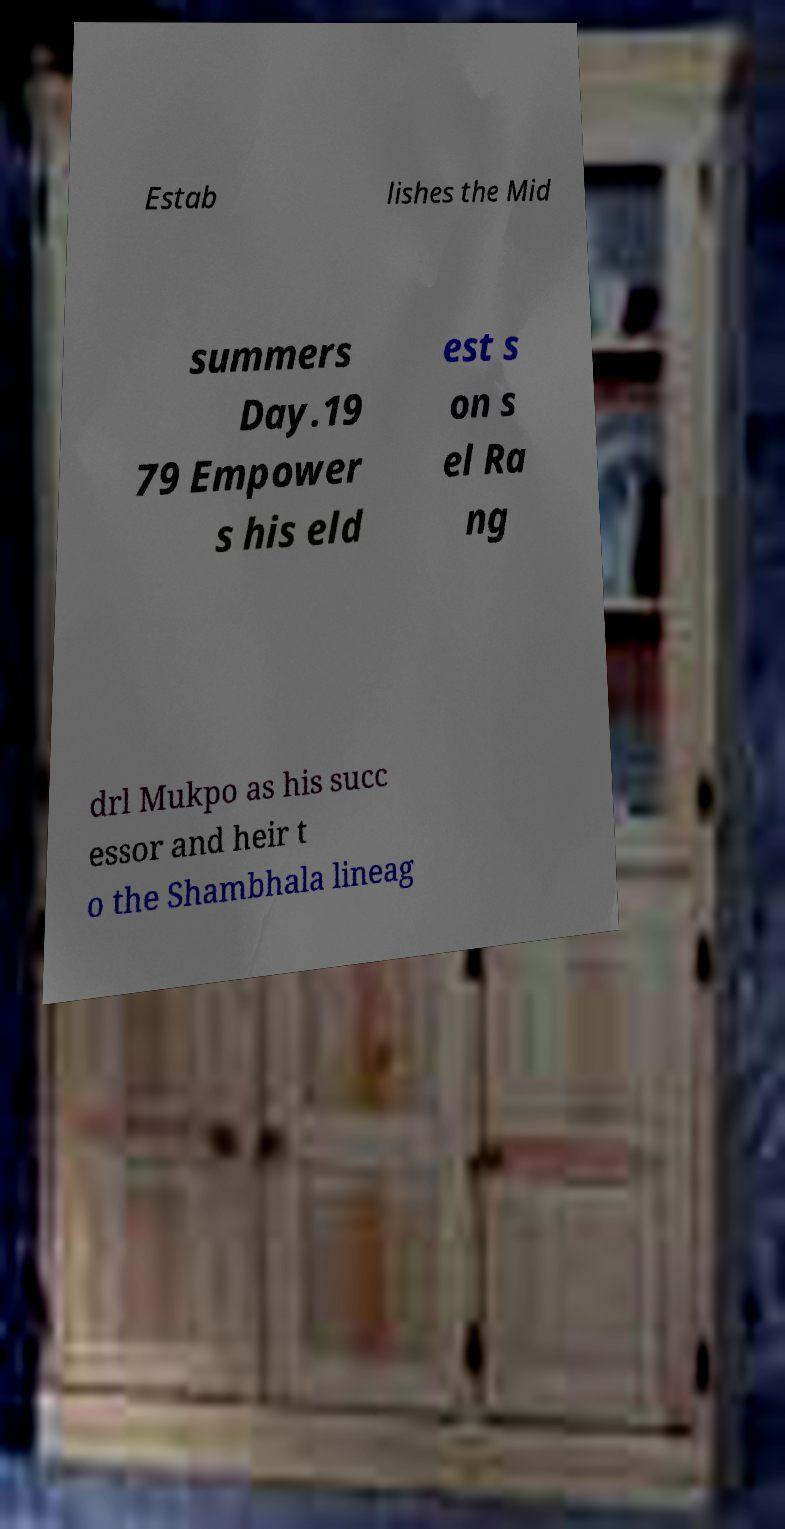Can you read and provide the text displayed in the image?This photo seems to have some interesting text. Can you extract and type it out for me? Estab lishes the Mid summers Day.19 79 Empower s his eld est s on s el Ra ng drl Mukpo as his succ essor and heir t o the Shambhala lineag 